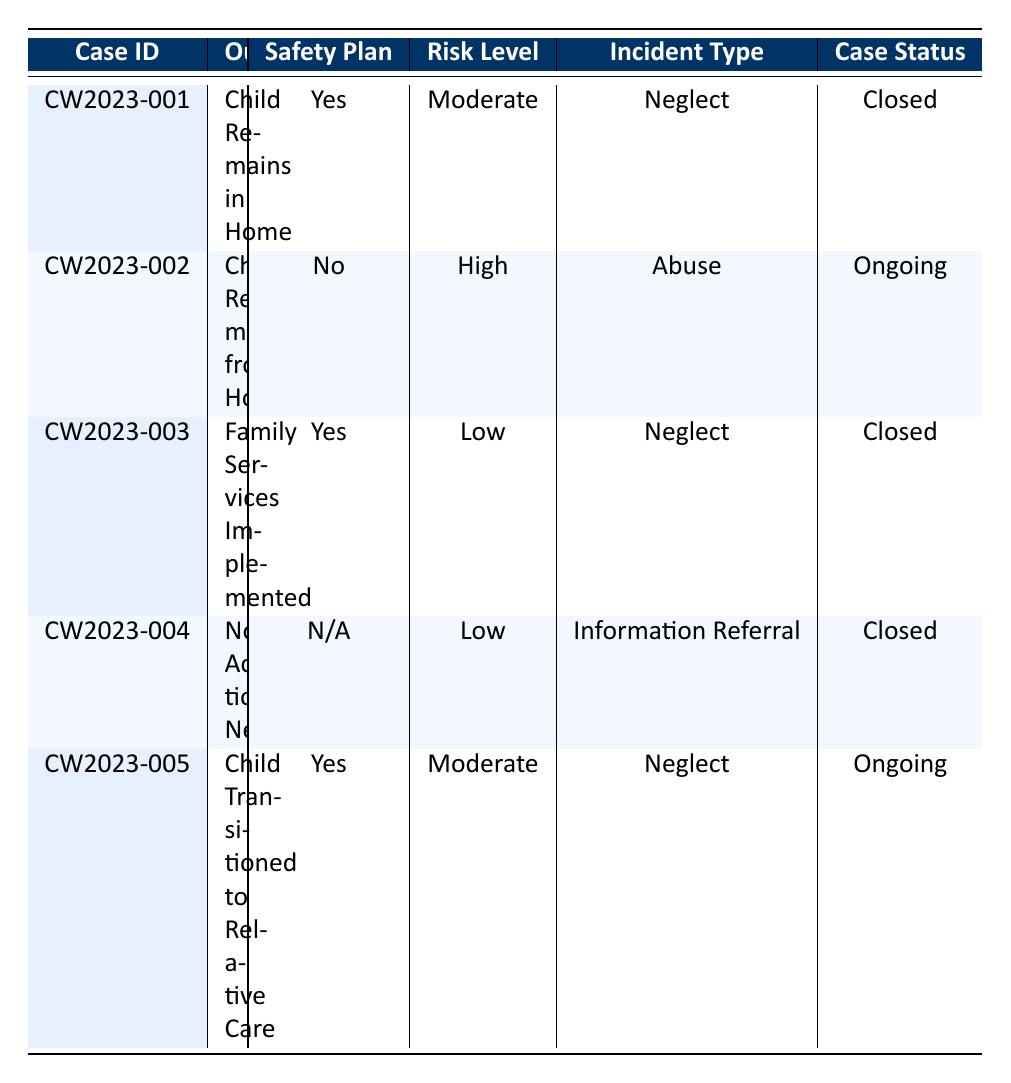What is the outcome for case CW2023-001? The table states that the outcome for case CW2023-001 is "Child Remains in Home."
Answer: Child Remains in Home How many cases have a safety plan in place? Referring to the table, there are three cases with a safety plan: CW2023-001, CW2023-003, and CW2023-005.
Answer: 3 Is the risk level for case CW2023-002 classified as low? The table indicates that the risk level for case CW2023-002 is "High," not low.
Answer: No What is the follow-up date for the case with the outcome "No Action Needed"? The follow-up date for the case with the outcome "No Action Needed" (case CW2023-004) is listed as "2023-02-20."
Answer: 2023-02-20 What is the average risk level across the cases? The risk levels are categorized as follows: High (1), Moderate (2), and Low (2). To find the average, we must sum the numerical values assigned to each risk level here: (1*1 + 2*2 + 2*0)/5 = (1 + 4 + 0)/5 = 1/5 = 0.2, which corresponds to a Risk Level of Moderate.
Answer: Moderate How many cases in the table have the case status "Ongoing"? By checking the table, we see that there are two cases with an "Ongoing" status: CW2023-002 and CW2023-005.
Answer: 2 Is there a case where the child was transitioned to relative care? The table shows that case CW2023-005 has the outcome "Child Transitioned to Relative Care." Therefore, the answer is yes.
Answer: Yes What was the incident type for the case with the highest risk level? The highest risk level is "High," which corresponds to case CW2023-002. The incident type for this case is "Abuse."
Answer: Abuse How many cases that are closed have a safety plan in place? The closed cases are CW2023-001, CW2023-003, and CW2023-004. Among these, CW2023-001 and CW2023-003 have a safety plan, totaling two cases with a safety plan in place.
Answer: 2 